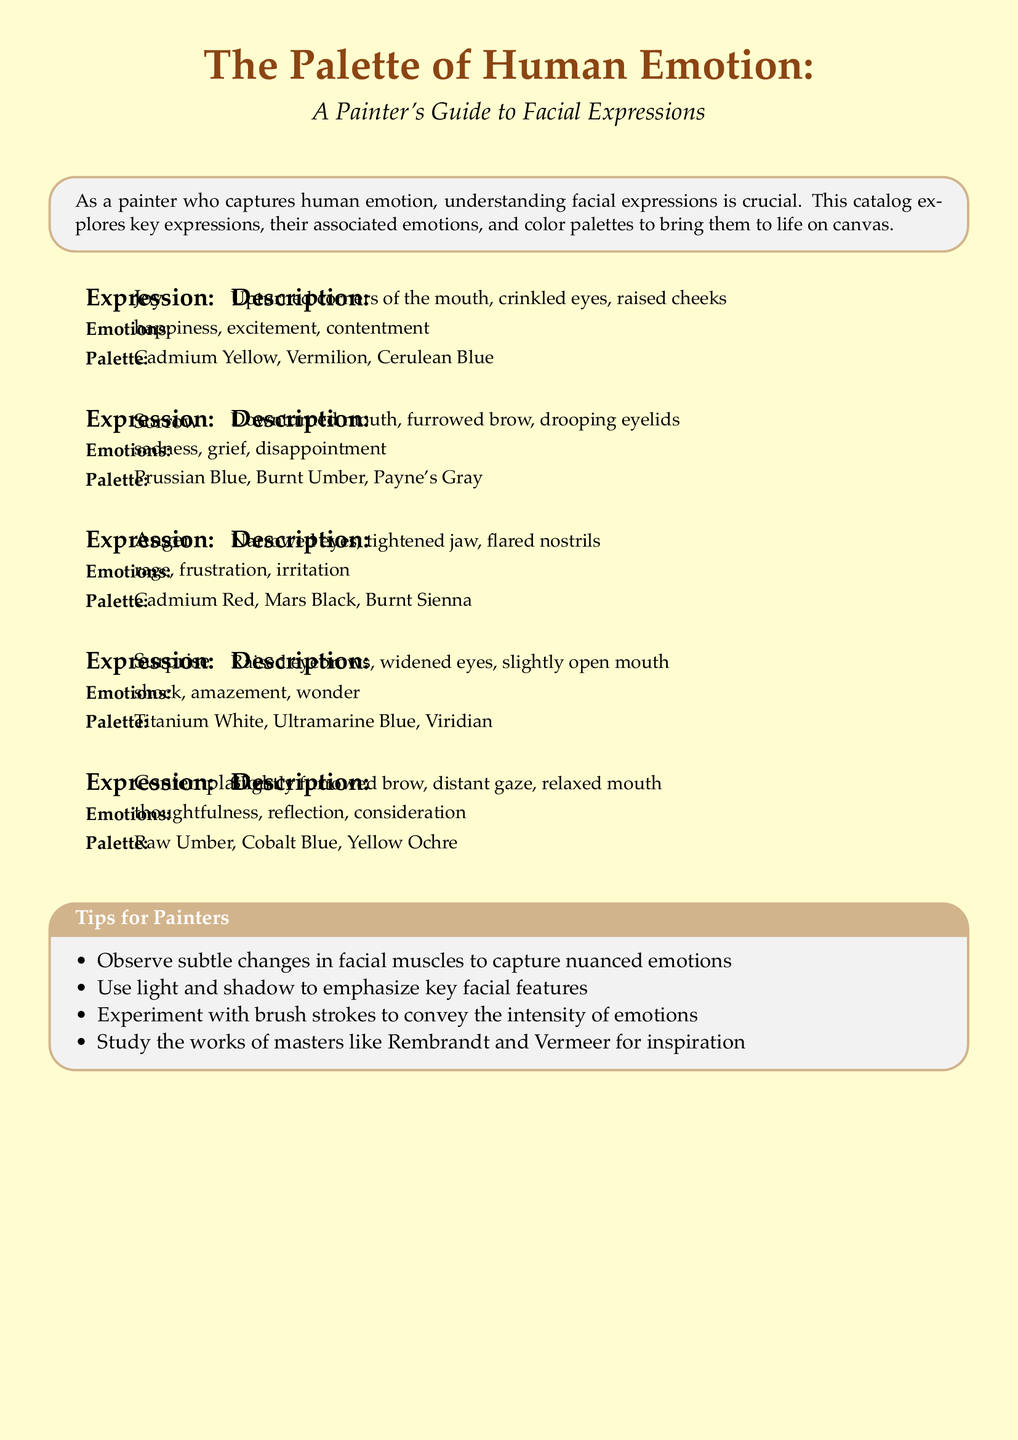what is the title of the catalog? The title is mentioned at the beginning of the document in a large font.
Answer: The Palette of Human Emotion how many facial expressions are described in the catalog? The catalog outlines five distinct facial expressions.
Answer: 5 what is the color palette associated with Joy? The color palette is listed under the Joy section in the document.
Answer: Cadmium Yellow, Vermilion, Cerulean Blue which emotion is associated with downturned mouth, furrowed brow, and drooping eyelids? These specific facial features correspond to a particular emotion listed in the Sorrow section.
Answer: Sorrow what is one tip for painters provided in the document? The document contains a section with practical tips for painters, which includes several suggestions.
Answer: Observe subtle changes in facial muscles to capture nuanced emotions which expression has narrowed eyes and a tightened jaw? This is detailed as a specific expression with emotions, located in the Anger section of the catalog.
Answer: Anger what colors are suggested for depicting Sorrow? The suggested colors for this expression are found in the corresponding palette section.
Answer: Prussian Blue, Burnt Umber, Payne's Gray what type of gaze is described in the expression Contemplation? This describes the type of gaze used to represent a specific emotion that's included in the Contemplation section.
Answer: Distant gaze 